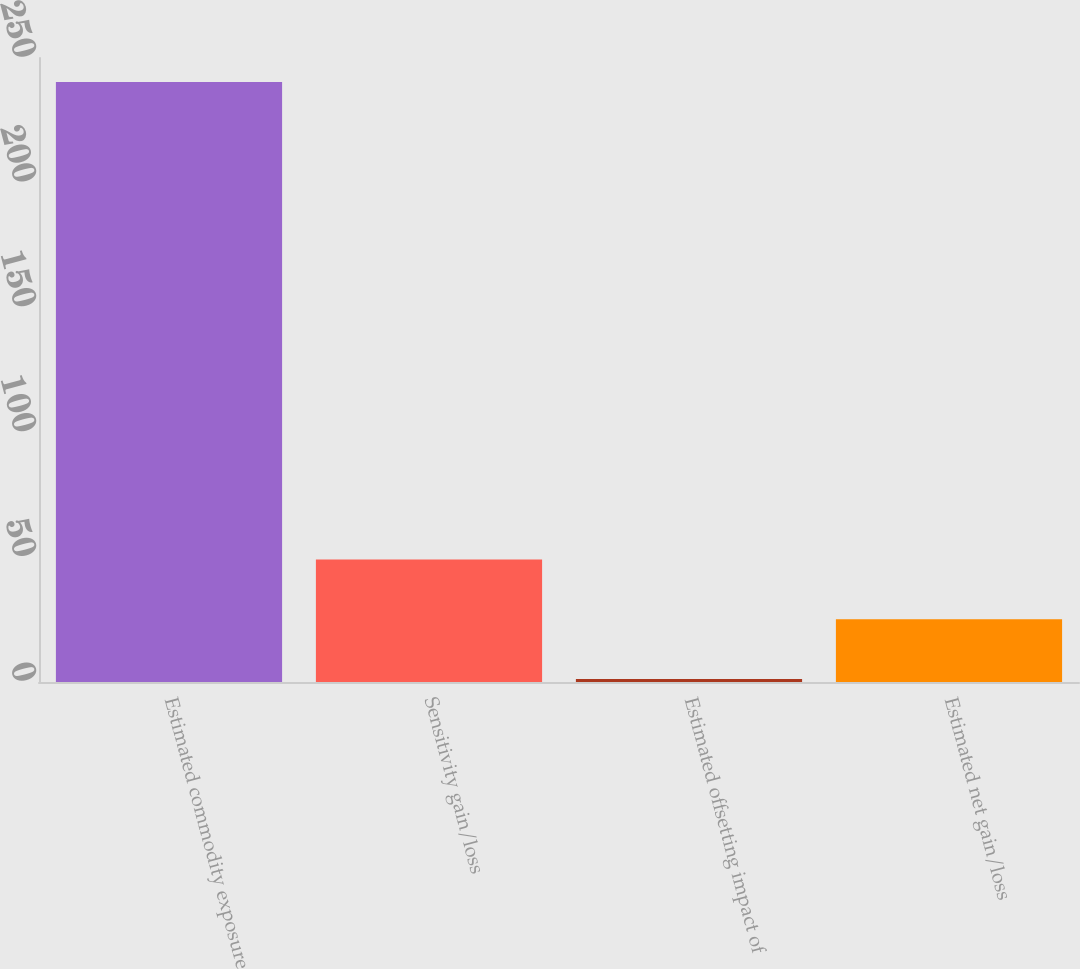Convert chart. <chart><loc_0><loc_0><loc_500><loc_500><bar_chart><fcel>Estimated commodity exposure<fcel>Sensitivity gain/loss<fcel>Estimated offsetting impact of<fcel>Estimated net gain/loss<nl><fcel>240.4<fcel>49.04<fcel>1.2<fcel>25.12<nl></chart> 